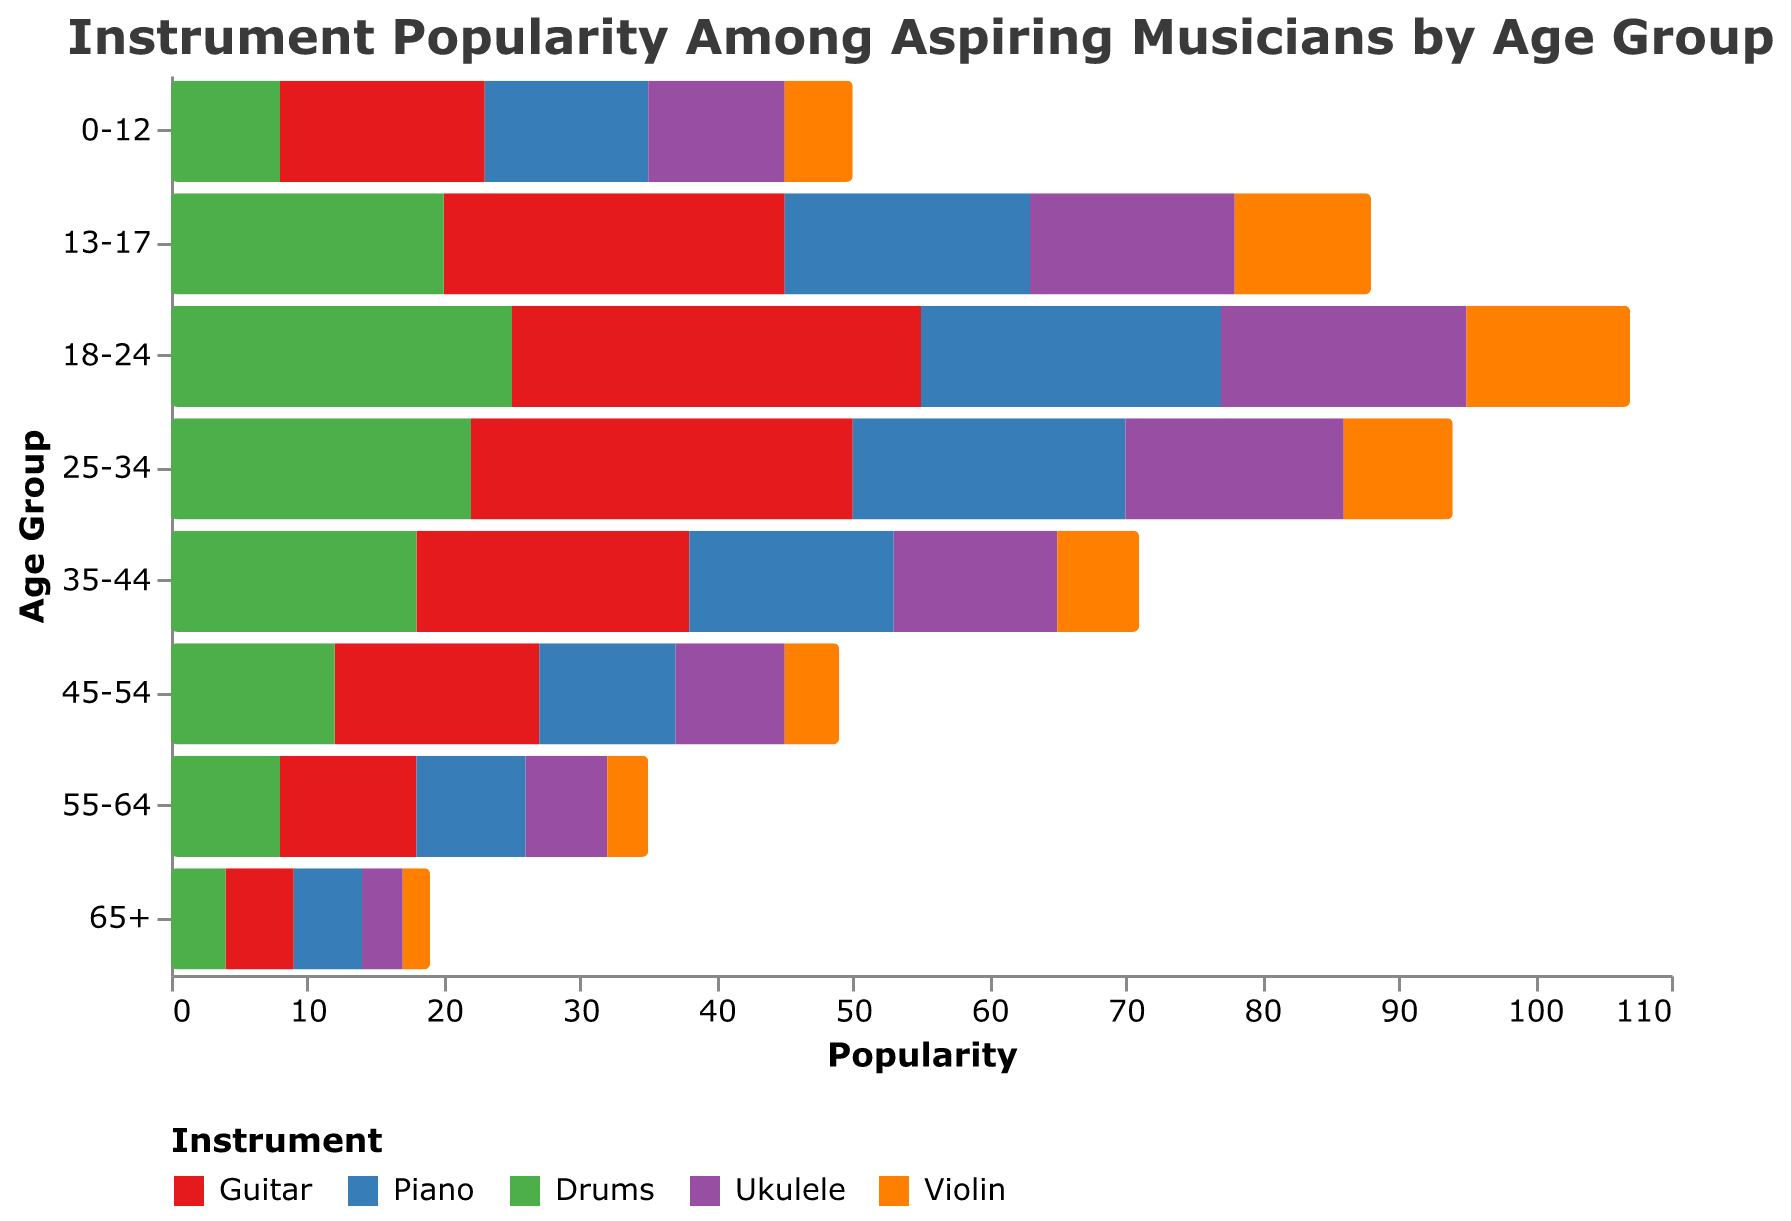How many age groups are displayed in the figure? The figure contains one bar for each age group, and each bar represents populations for five different instruments. Count the labels on the y-axis to determine the number of age groups.
Answer: 8 Which instrument is most popular among the 25-34 age group? Look at the 25-34 age group's bars and compare their lengths. The bar representing the most positive value on the x-axis indicates the most popular instrument for that age group.
Answer: Piano What is the difference in guitar popularity between the 18-24 and 65+ age groups? Find the values for guitar in both age groups. Convert them to positive values if necessary (since negative values are used for specific instruments). Calculate the absolute difference. The values for guitar in the 18-24 age group and the 65+ age group are -30 and -5, respectively. So, the difference is
Answer: 25 Which age group has the least popularity for ukulele? Compare the values for ukulele across all age groups. The group with the smallest positive number or the lowest value on the x-axis indicates the least popularity.
Answer: 65+ How many instruments are represented in total in the figure? Identify each unique color or label in the legend. Since each instrument is represented by a unique color, count the total number of unique instruments listed in the legend.
Answer: 5 What is the overall trend in piano popularity as age increases? Observe the bars representing piano across all age groups from 0-12 to 65+. Determine whether the values generally increase, decrease, or remain constant as you move from younger to older age groups. The popularity of the piano shows a decreasing trend as age increases.
Answer: Decreasing How does the popularity of violin compare between the 0-12 and 35-44 age groups? Find the values for violin in both the 0-12 and 35-44 age groups. Compare the values to see which is greater. The values for violin in the 0-12 and 35-44 age groups are -5 and -6, respectively. Violin is more popular in the 0-12 age group compared to the 35-44 age group.
Answer: 0-12 is more popular What is the sum of popularity values for piano across all age groups? Collect the popularity values for piano from all age groups: 12, 18, 22, 20, 15, 10, 8, 5. Sum these values to get the total popularity for piano across all age groups. So, the sum is 12 + 18 + 22 + 20 + 15 + 10 + 8 + 5 = 110.
Answer: 110 Which instrument shows a consistent decreasing trend with increasing age? Examine the population values for each instrument across all age groups. Determine if any of the instruments consistently show decreasing values as the age groups progress. Guitar shows a consistent decreasing trend as the age increases.
Answer: Guitar 